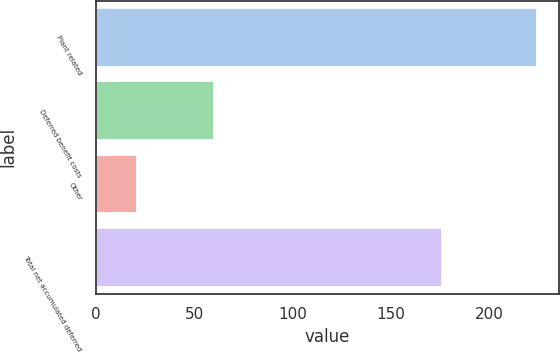Convert chart to OTSL. <chart><loc_0><loc_0><loc_500><loc_500><bar_chart><fcel>Plant related<fcel>Deferred benefit costs<fcel>Other<fcel>Total net accumulated deferred<nl><fcel>224<fcel>60<fcel>21<fcel>176<nl></chart> 